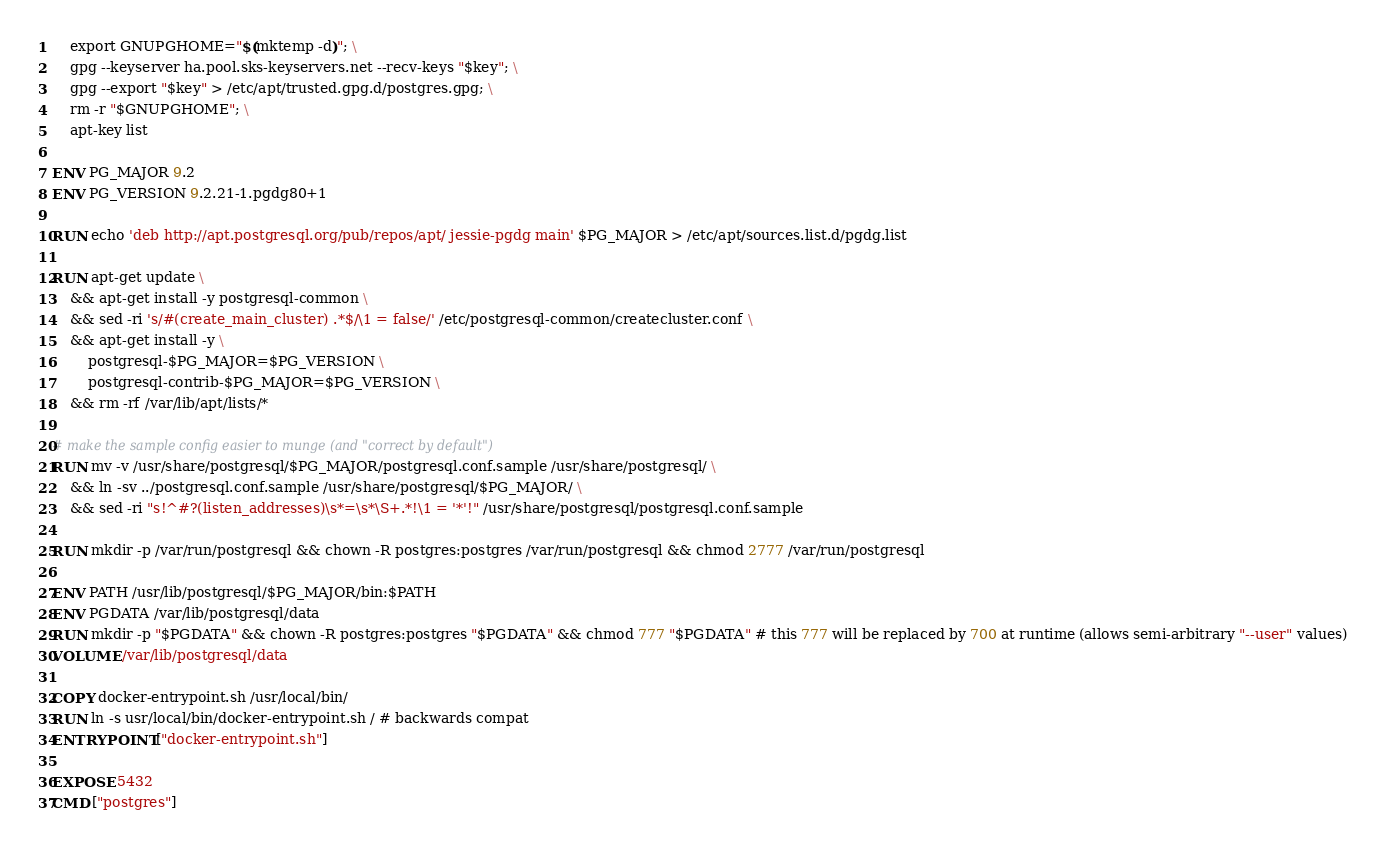Convert code to text. <code><loc_0><loc_0><loc_500><loc_500><_Dockerfile_>	export GNUPGHOME="$(mktemp -d)"; \
	gpg --keyserver ha.pool.sks-keyservers.net --recv-keys "$key"; \
	gpg --export "$key" > /etc/apt/trusted.gpg.d/postgres.gpg; \
	rm -r "$GNUPGHOME"; \
	apt-key list

ENV PG_MAJOR 9.2
ENV PG_VERSION 9.2.21-1.pgdg80+1

RUN echo 'deb http://apt.postgresql.org/pub/repos/apt/ jessie-pgdg main' $PG_MAJOR > /etc/apt/sources.list.d/pgdg.list

RUN apt-get update \
	&& apt-get install -y postgresql-common \
	&& sed -ri 's/#(create_main_cluster) .*$/\1 = false/' /etc/postgresql-common/createcluster.conf \
	&& apt-get install -y \
		postgresql-$PG_MAJOR=$PG_VERSION \
		postgresql-contrib-$PG_MAJOR=$PG_VERSION \
	&& rm -rf /var/lib/apt/lists/*

# make the sample config easier to munge (and "correct by default")
RUN mv -v /usr/share/postgresql/$PG_MAJOR/postgresql.conf.sample /usr/share/postgresql/ \
	&& ln -sv ../postgresql.conf.sample /usr/share/postgresql/$PG_MAJOR/ \
	&& sed -ri "s!^#?(listen_addresses)\s*=\s*\S+.*!\1 = '*'!" /usr/share/postgresql/postgresql.conf.sample

RUN mkdir -p /var/run/postgresql && chown -R postgres:postgres /var/run/postgresql && chmod 2777 /var/run/postgresql

ENV PATH /usr/lib/postgresql/$PG_MAJOR/bin:$PATH
ENV PGDATA /var/lib/postgresql/data
RUN mkdir -p "$PGDATA" && chown -R postgres:postgres "$PGDATA" && chmod 777 "$PGDATA" # this 777 will be replaced by 700 at runtime (allows semi-arbitrary "--user" values)
VOLUME /var/lib/postgresql/data

COPY docker-entrypoint.sh /usr/local/bin/
RUN ln -s usr/local/bin/docker-entrypoint.sh / # backwards compat
ENTRYPOINT ["docker-entrypoint.sh"]

EXPOSE 5432
CMD ["postgres"]
</code> 